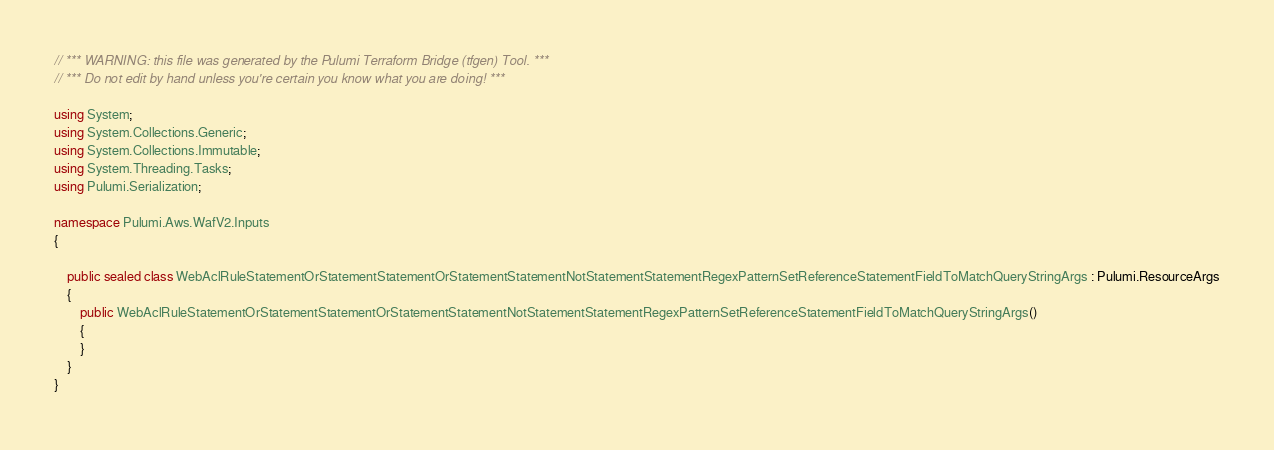Convert code to text. <code><loc_0><loc_0><loc_500><loc_500><_C#_>// *** WARNING: this file was generated by the Pulumi Terraform Bridge (tfgen) Tool. ***
// *** Do not edit by hand unless you're certain you know what you are doing! ***

using System;
using System.Collections.Generic;
using System.Collections.Immutable;
using System.Threading.Tasks;
using Pulumi.Serialization;

namespace Pulumi.Aws.WafV2.Inputs
{

    public sealed class WebAclRuleStatementOrStatementStatementOrStatementStatementNotStatementStatementRegexPatternSetReferenceStatementFieldToMatchQueryStringArgs : Pulumi.ResourceArgs
    {
        public WebAclRuleStatementOrStatementStatementOrStatementStatementNotStatementStatementRegexPatternSetReferenceStatementFieldToMatchQueryStringArgs()
        {
        }
    }
}
</code> 